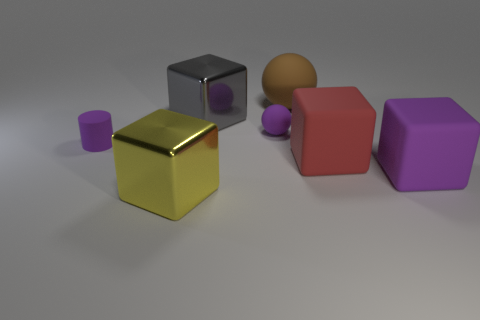Add 1 big cyan cylinders. How many objects exist? 8 Subtract all big red matte cubes. How many cubes are left? 3 Subtract all red blocks. How many blocks are left? 3 Subtract 2 cubes. How many cubes are left? 2 Subtract all cyan cubes. Subtract all gray cylinders. How many cubes are left? 4 Subtract all blue cylinders. How many purple balls are left? 1 Subtract all big red rubber things. Subtract all brown balls. How many objects are left? 5 Add 6 big gray blocks. How many big gray blocks are left? 7 Add 1 large red rubber blocks. How many large red rubber blocks exist? 2 Subtract 0 red balls. How many objects are left? 7 